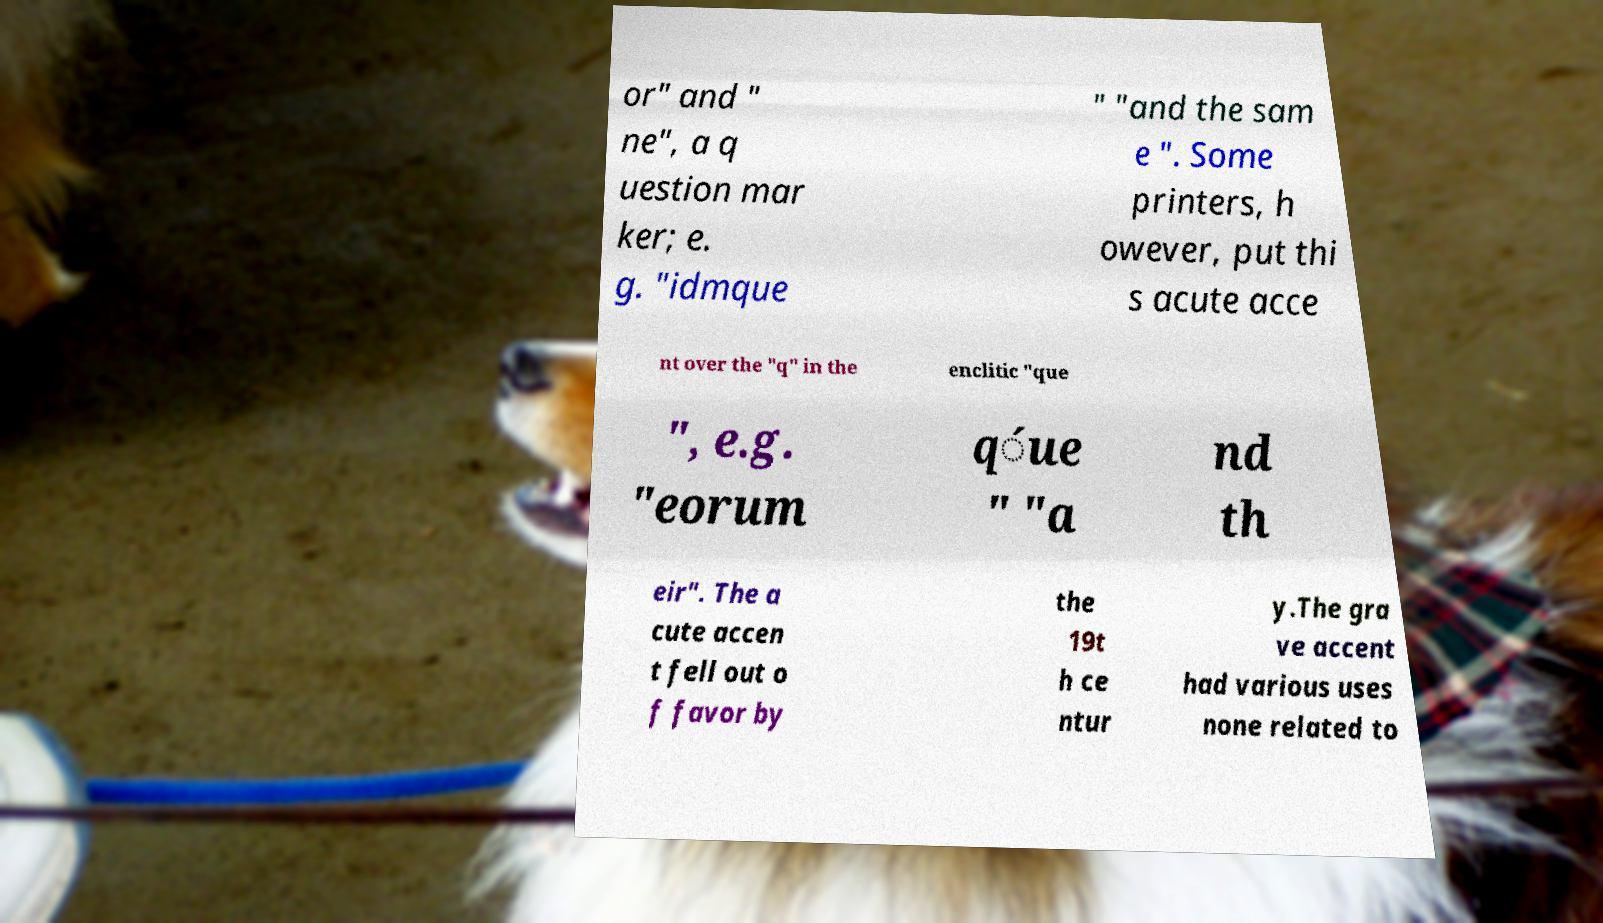Can you accurately transcribe the text from the provided image for me? or" and " ne", a q uestion mar ker; e. g. "idmque " "and the sam e ". Some printers, h owever, put thi s acute acce nt over the "q" in the enclitic "que ", e.g. "eorum q́ue " "a nd th eir". The a cute accen t fell out o f favor by the 19t h ce ntur y.The gra ve accent had various uses none related to 